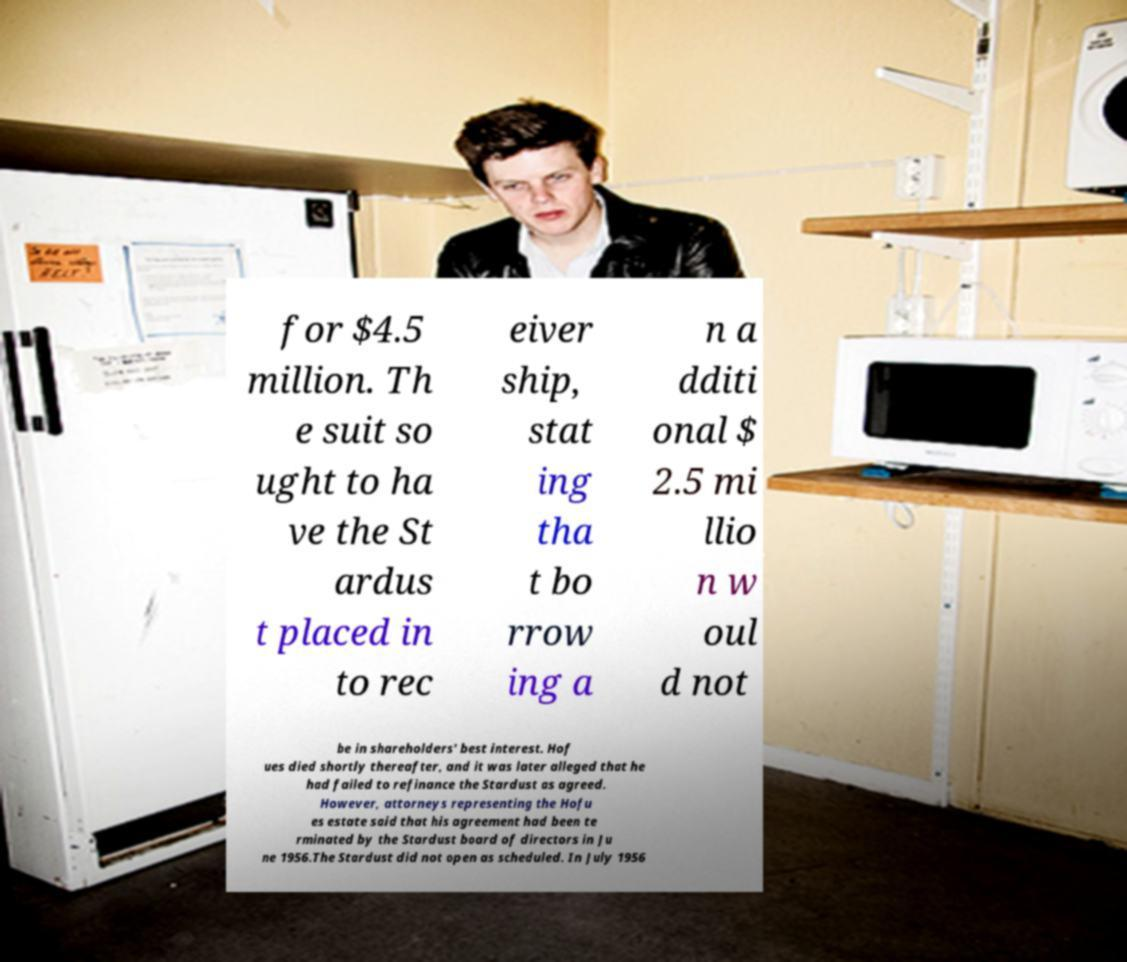Could you assist in decoding the text presented in this image and type it out clearly? for $4.5 million. Th e suit so ught to ha ve the St ardus t placed in to rec eiver ship, stat ing tha t bo rrow ing a n a dditi onal $ 2.5 mi llio n w oul d not be in shareholders' best interest. Hof ues died shortly thereafter, and it was later alleged that he had failed to refinance the Stardust as agreed. However, attorneys representing the Hofu es estate said that his agreement had been te rminated by the Stardust board of directors in Ju ne 1956.The Stardust did not open as scheduled. In July 1956 